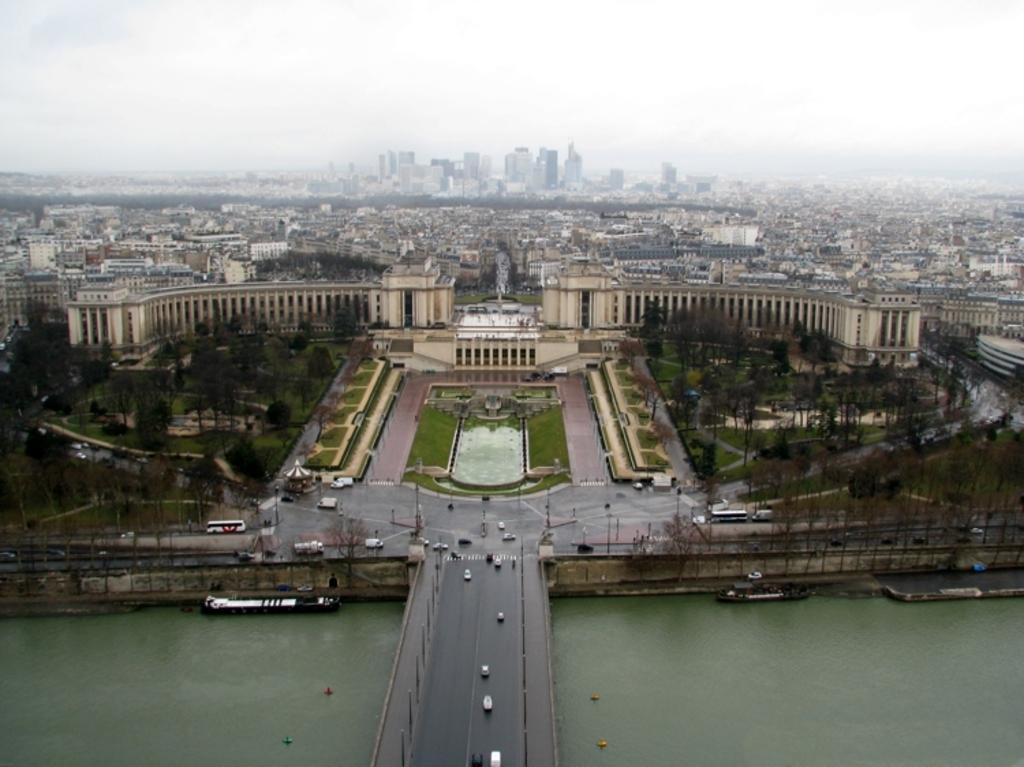Please provide a concise description of this image. Down side it's a bridge. This is water and here it is a building. At the top it's a sky. 